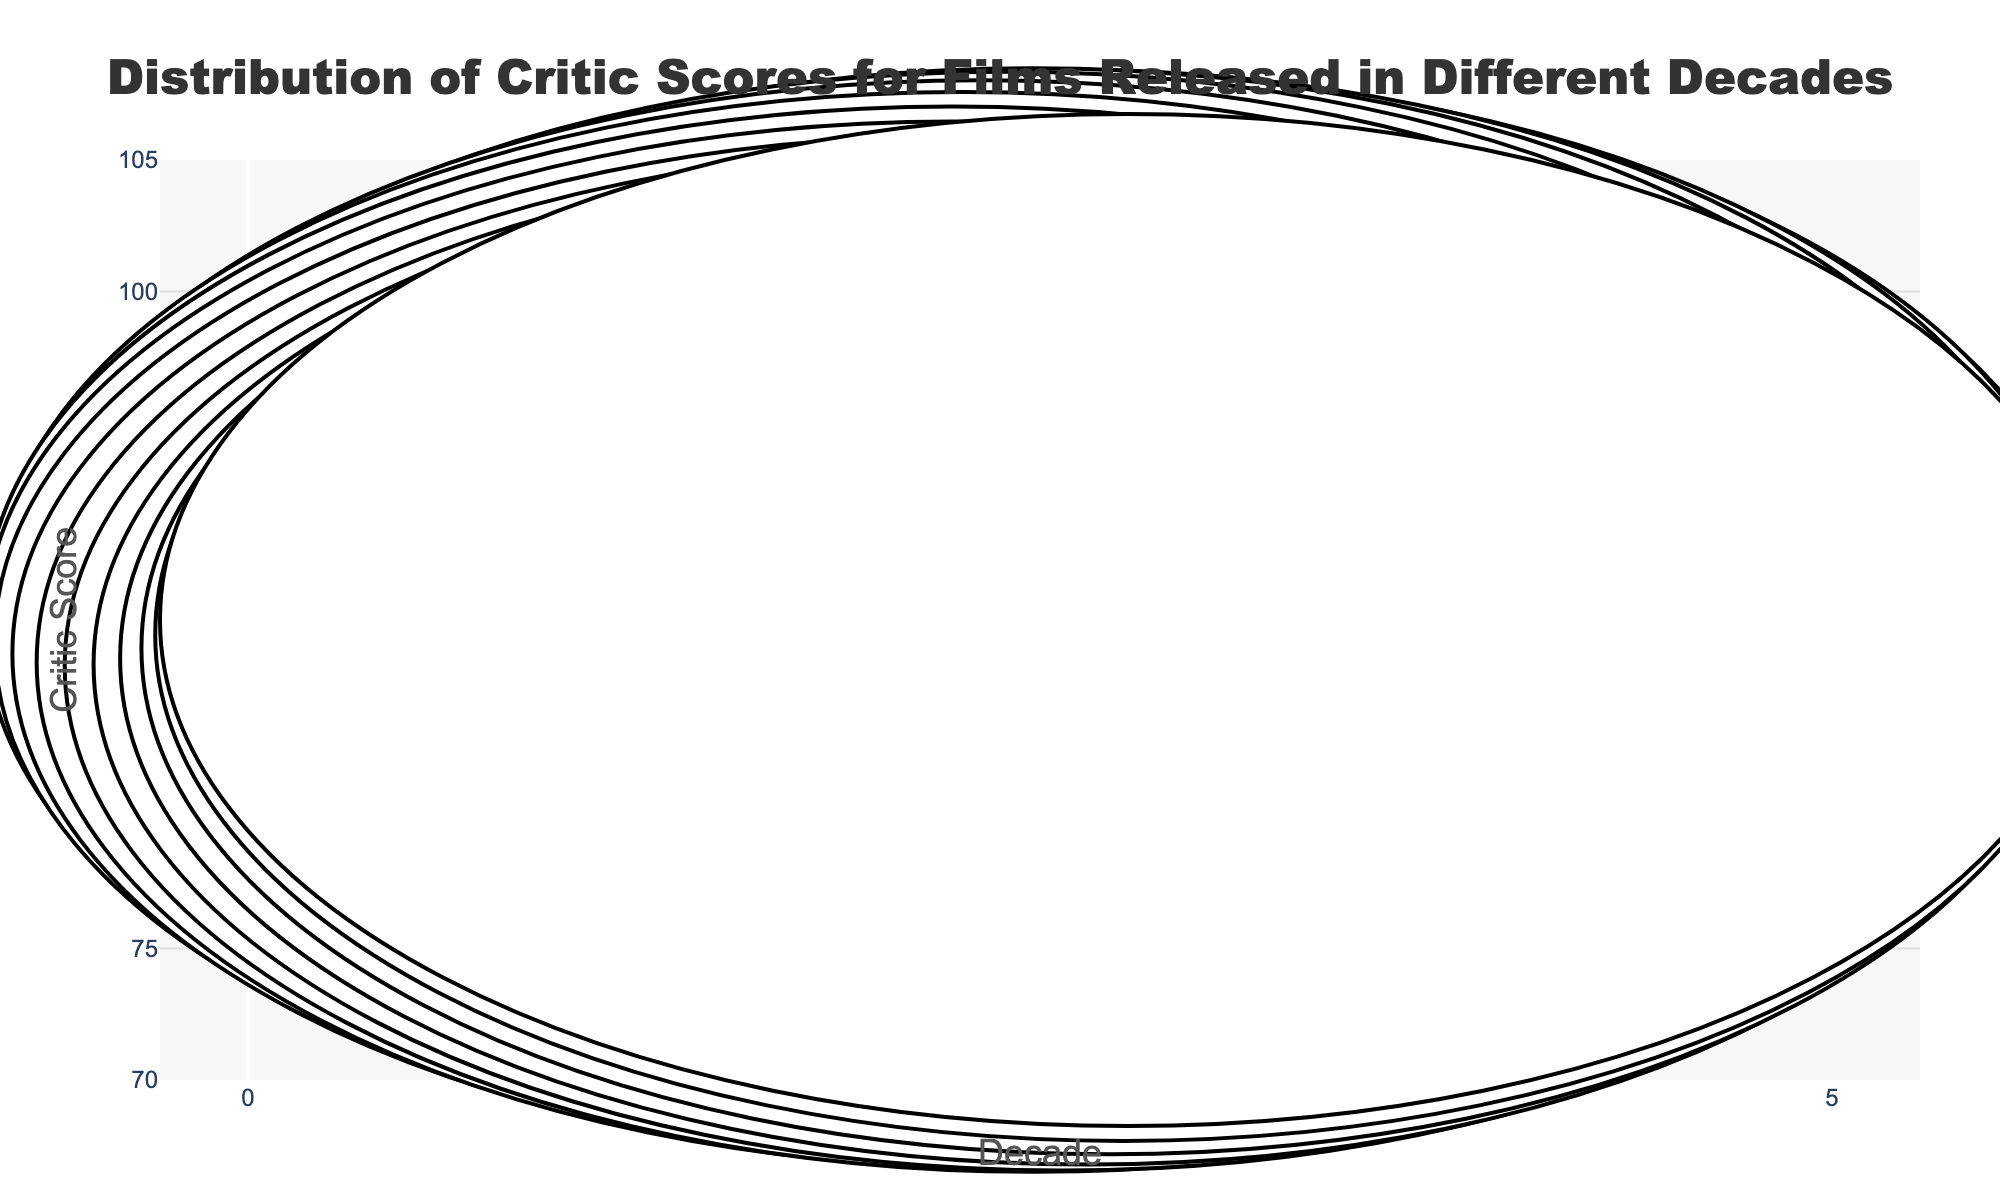What is the title of the figure? The title of the figure is displayed at the top of the plot in a large font. It should be the most prominent text and is usually intended to summarize the content of the figure.
Answer: Distribution of Critic Scores for Films Released in Different Decades Which decade has the movie with the highest critic score? By reviewing the plot, we look for the highest point that extends furthest along the 'Critic Score' axis. The tooltip or hover information reveals the movie title.
Answer: 2010s How many films are included in the 1990s decade? Count the number of individual points within the 1990s violin plot to determine the number of films represented.
Answer: 6 Which decade has the widest distribution of critic scores? The width of the violin plot represents the variability in critic scores. The decade with the broadest plot width has the widest distribution.
Answer: 2000s How does the median critic score of the 2010s compare to that of the 1980s? Identify the approximate center of the density distribution for both decades. The central points or thickest parts of the violin plots typically represent the median scores. Compare these points visually.
Answer: Higher What is the lowest critic score for the 2000s? Identify the lowest point of the violin plot for the 2000s. The bottom-most point represents the lowest critic score.
Answer: 77 What is the range of critic scores for the 1980s? Determine the highest and lowest points on the 1980s violin plot. Subtract the lowest score from the highest score to find the range.
Answer: 94 - 86 = 8 Which decade has the most films with scores above 90? Count the number of individual points above the score of 90 in each decade. The decade with the most points above this threshold has the most films with scores above 90.
Answer: 2010s Are there any decades where all films have scores above 85? Check each decade’s violin plot to see if all the points are above the score of 85. Only the decades with all points above this line meet this condition.
Answer: 1980s and 2020s What is the average critic score for films in the 1990s? Add all the critic scores for films in the 1990s and divide by the number of films to find the average. Scores are: 96, 94, 91, 79, 88, 87. Sum = 535. Number of films = 6. Average = 535 / 6.
Answer: 89.17 